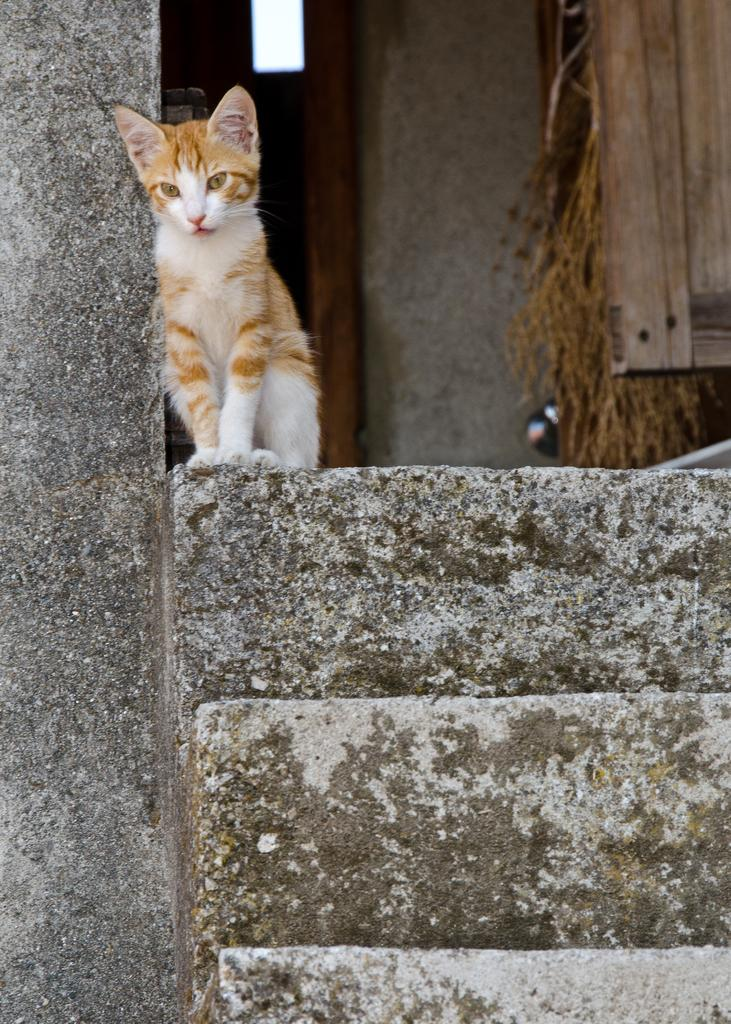What is located in front of the image? There are steps in front of the image. What animal can be seen beside a pillar in the image? There is a cat beside a pillar in the image. What can be found in the background on the right side of the image? There is a door in the background on the right side of the image. What is present in the background of the image? There is a wall in the background of the image. What type of seed is being planted by the cat in the image? There is no seed or planting activity present in the image; it features a cat beside a pillar and other architectural elements. What action is the tent performing in the image? There is no tent present in the image, so it is not possible to describe any actions it might be performing. 